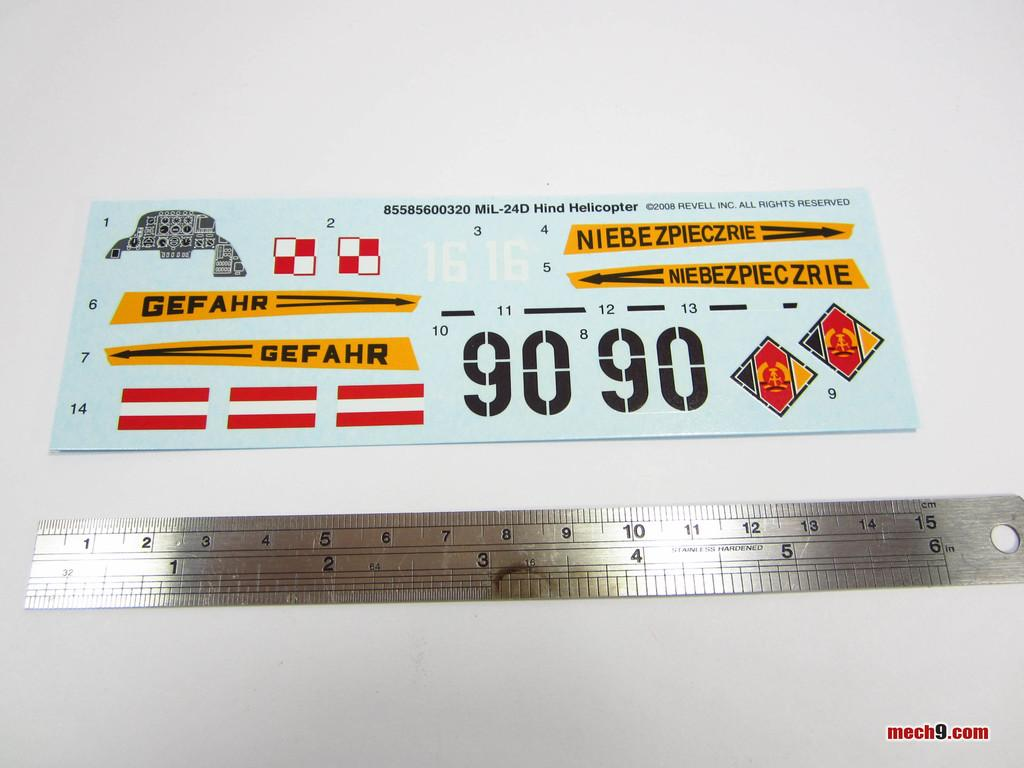<image>
Relay a brief, clear account of the picture shown. Appears to be a sheet of stickers saying things like Gefahr. 